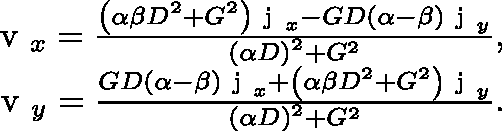Convert formula to latex. <formula><loc_0><loc_0><loc_500><loc_500>\begin{array} { r } { \boldmath v _ { x } = \frac { \left ( \alpha \beta D ^ { 2 } + G ^ { 2 } \right ) \boldmath j _ { x } - G D \left ( \alpha - \beta \right ) \boldmath j _ { y } } { \left ( \alpha D \right ) ^ { 2 } + G ^ { 2 } } , } \\ { \boldmath v _ { y } = \frac { G D \left ( \alpha - \beta \right ) \boldmath j _ { x } + \left ( \alpha \beta D ^ { 2 } + G ^ { 2 } \right ) \boldmath j _ { y } } { \left ( \alpha D \right ) ^ { 2 } + G ^ { 2 } } . } \end{array}</formula> 